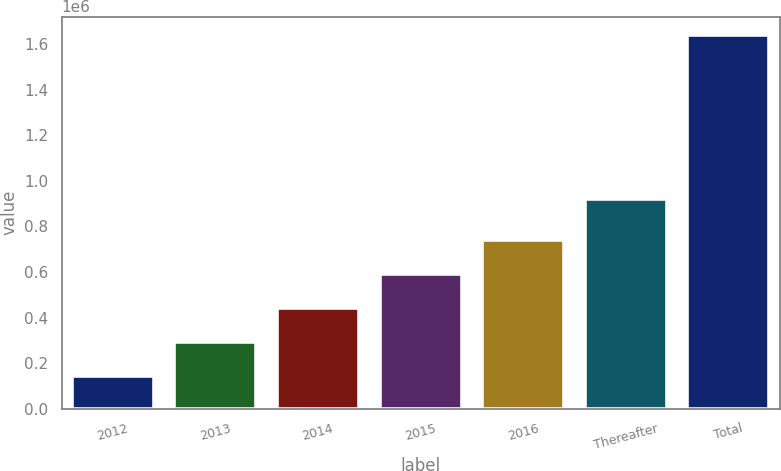Convert chart. <chart><loc_0><loc_0><loc_500><loc_500><bar_chart><fcel>2012<fcel>2013<fcel>2014<fcel>2015<fcel>2016<fcel>Thereafter<fcel>Total<nl><fcel>144231<fcel>293786<fcel>443342<fcel>592897<fcel>742452<fcel>918629<fcel>1.63978e+06<nl></chart> 